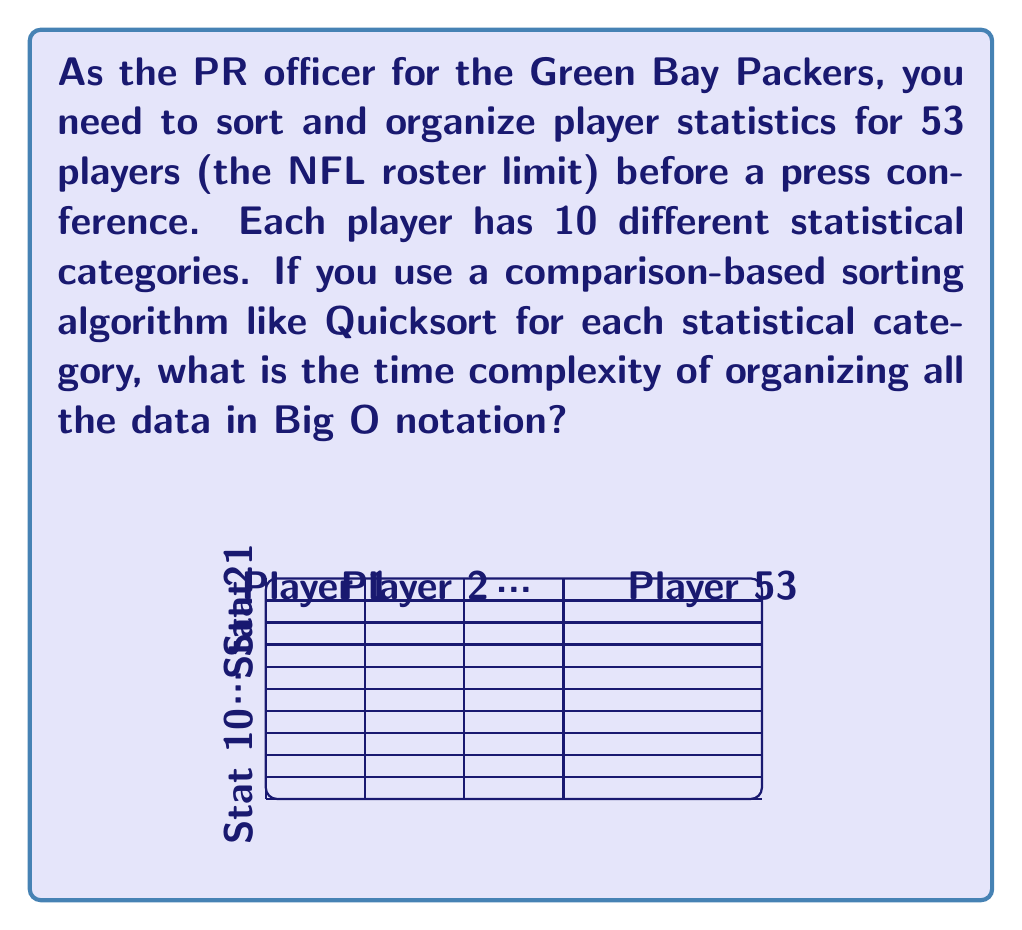Show me your answer to this math problem. Let's break this down step-by-step:

1) We have 53 players, each with 10 statistical categories. This means we need to sort 10 different lists, each containing 53 elements.

2) The time complexity of Quicksort for a single list of n elements is, on average, $O(n \log n)$.

3) In our case, for each statistical category:
   - n = 53 (number of players)
   - Time complexity for one category: $O(53 \log 53)$

4) We need to perform this sorting for all 10 statistical categories. When we have a fixed number of operations, we multiply the time complexity:

   Total time complexity = $10 \times O(53 \log 53)$

5) In Big O notation, we can simplify this:
   - Constants (like 10 and 53) are dropped
   - We're left with $O(n \log n)$, where n represents the number of players

6) However, since we're performing this operation 10 times (once for each stat), we should represent this in our final answer.

Therefore, the overall time complexity is $O(k \cdot n \log n)$, where k is the number of statistical categories and n is the number of players.
Answer: $O(k \cdot n \log n)$ 